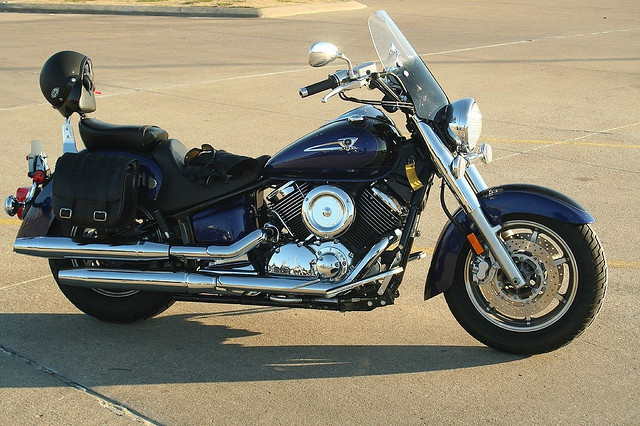Describe the objects in this image and their specific colors. I can see a motorcycle in tan, black, gray, darkgray, and ivory tones in this image. 